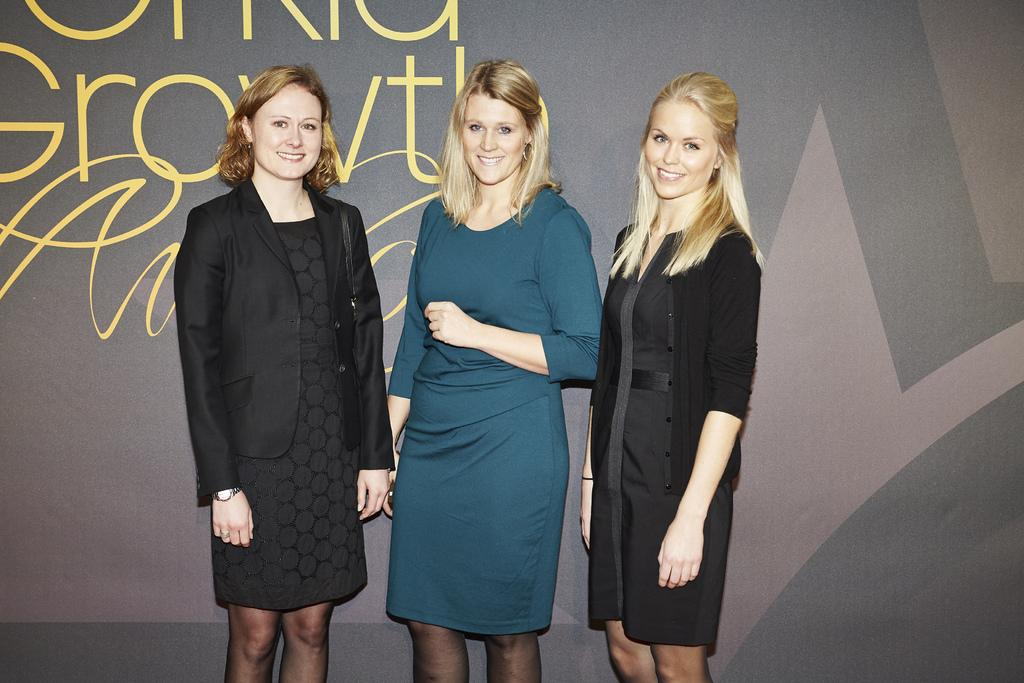How many women are in the image? There are three women in the foreground of the image. What are the women doing in the image? The women are standing and posing for a camera. What can be seen in the background of the image? There is a wall visible in the background of the image. Can you see a rabbit sitting on a table in the image? No, there is no rabbit or table present in the image. 